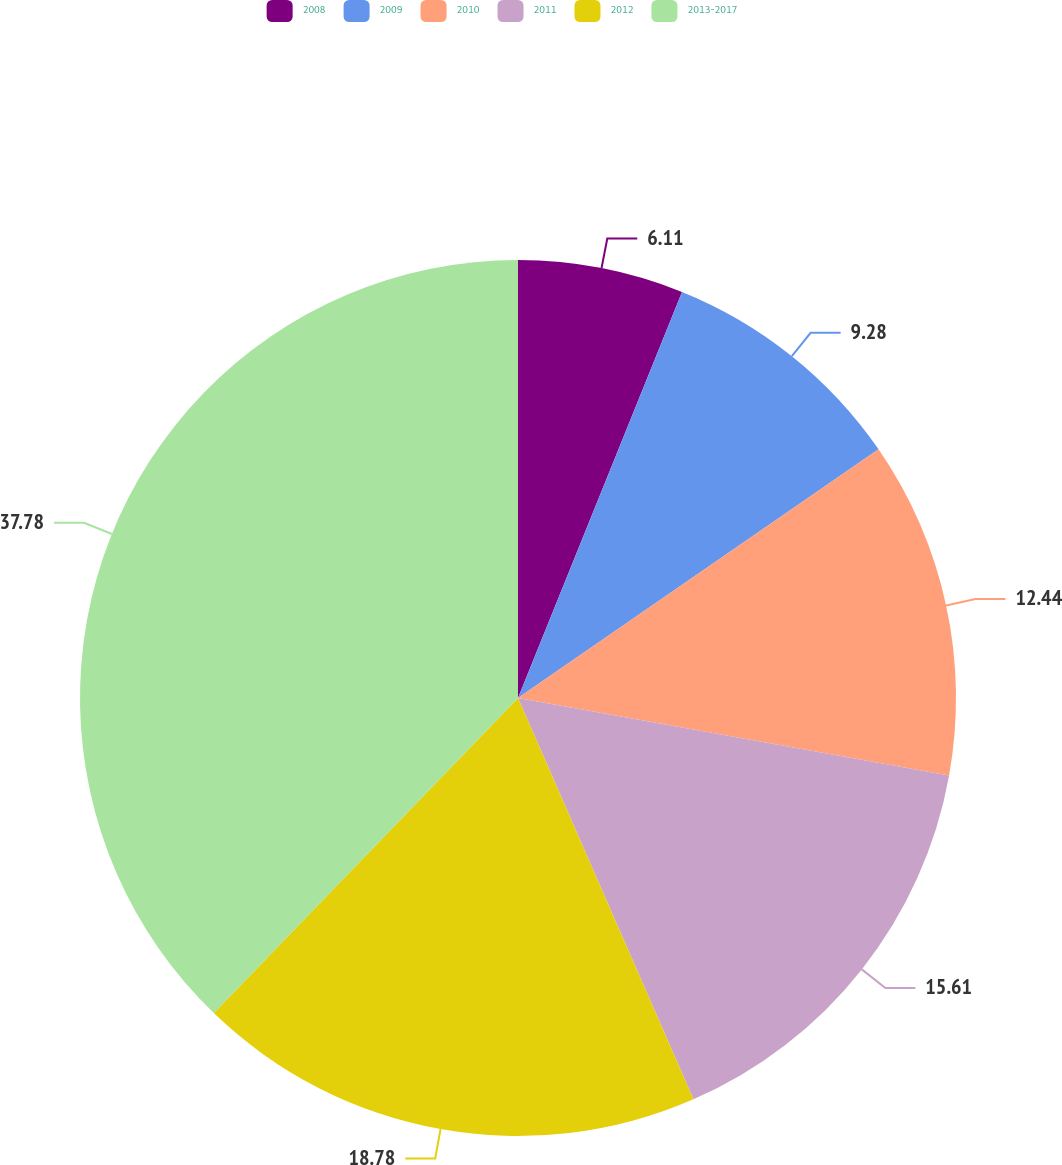Convert chart. <chart><loc_0><loc_0><loc_500><loc_500><pie_chart><fcel>2008<fcel>2009<fcel>2010<fcel>2011<fcel>2012<fcel>2013-2017<nl><fcel>6.11%<fcel>9.28%<fcel>12.44%<fcel>15.61%<fcel>18.78%<fcel>37.78%<nl></chart> 